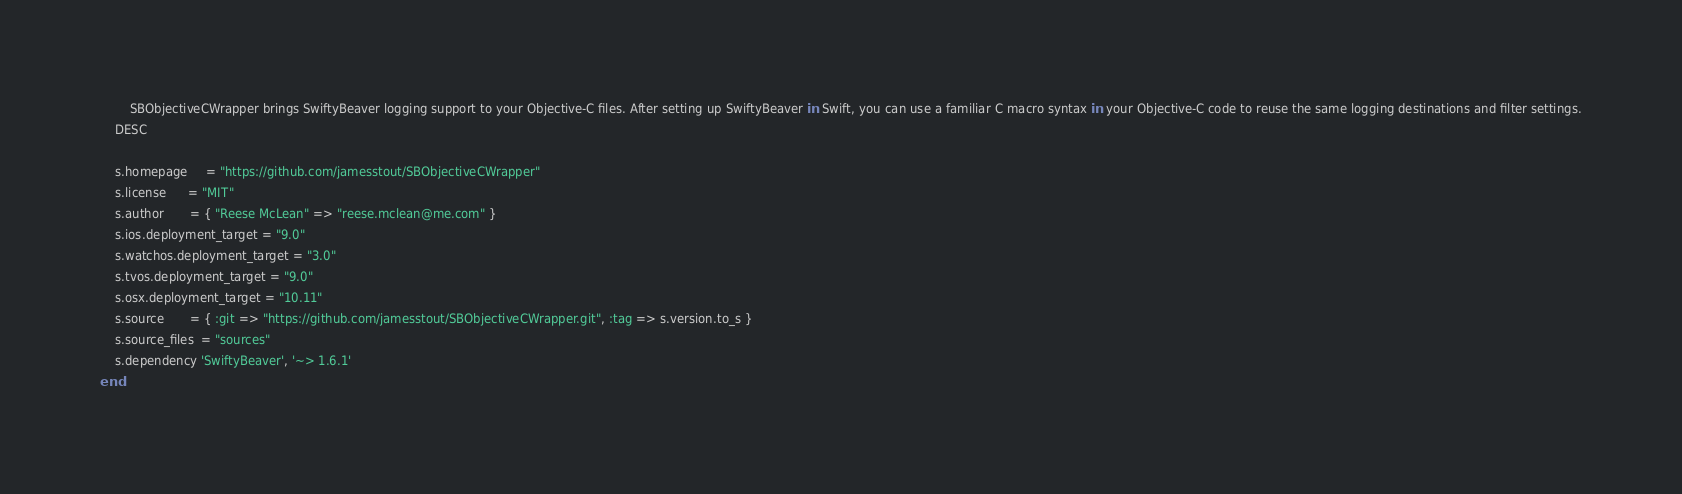Convert code to text. <code><loc_0><loc_0><loc_500><loc_500><_Ruby_>        SBObjectiveCWrapper brings SwiftyBeaver logging support to your Objective-C files. After setting up SwiftyBeaver in Swift, you can use a familiar C macro syntax in your Objective-C code to reuse the same logging destinations and filter settings.
    DESC

    s.homepage     = "https://github.com/jamesstout/SBObjectiveCWrapper"
    s.license      = "MIT"
    s.author       = { "Reese McLean" => "reese.mclean@me.com" }
    s.ios.deployment_target = "9.0"
    s.watchos.deployment_target = "3.0"
    s.tvos.deployment_target = "9.0"
    s.osx.deployment_target = "10.11"
    s.source       = { :git => "https://github.com/jamesstout/SBObjectiveCWrapper.git", :tag => s.version.to_s }
    s.source_files  = "sources"
    s.dependency 'SwiftyBeaver', '~> 1.6.1'
end
</code> 